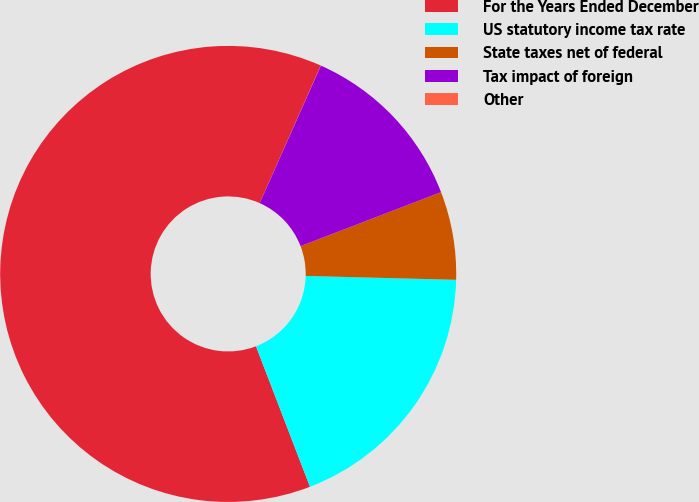Convert chart to OTSL. <chart><loc_0><loc_0><loc_500><loc_500><pie_chart><fcel>For the Years Ended December<fcel>US statutory income tax rate<fcel>State taxes net of federal<fcel>Tax impact of foreign<fcel>Other<nl><fcel>62.49%<fcel>18.75%<fcel>6.25%<fcel>12.5%<fcel>0.01%<nl></chart> 